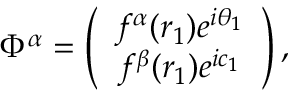<formula> <loc_0><loc_0><loc_500><loc_500>\Phi ^ { \alpha } = \left ( \begin{array} { c } { { f ^ { \alpha } ( r _ { 1 } ) e ^ { i \theta _ { 1 } } } } \\ { { f ^ { \beta } ( r _ { 1 } ) e ^ { i c _ { 1 } } } } \end{array} \right ) ,</formula> 